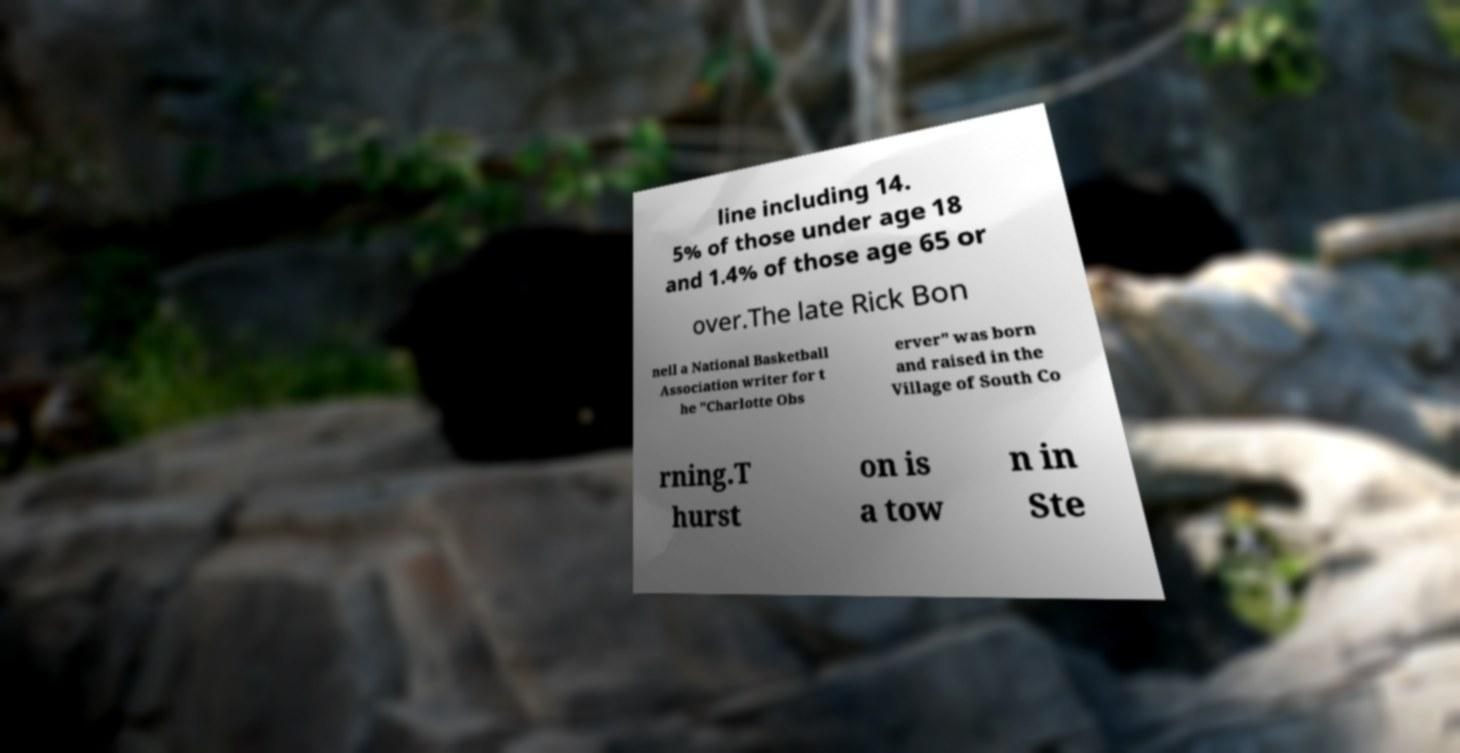Can you read and provide the text displayed in the image?This photo seems to have some interesting text. Can you extract and type it out for me? line including 14. 5% of those under age 18 and 1.4% of those age 65 or over.The late Rick Bon nell a National Basketball Association writer for t he "Charlotte Obs erver" was born and raised in the Village of South Co rning.T hurst on is a tow n in Ste 